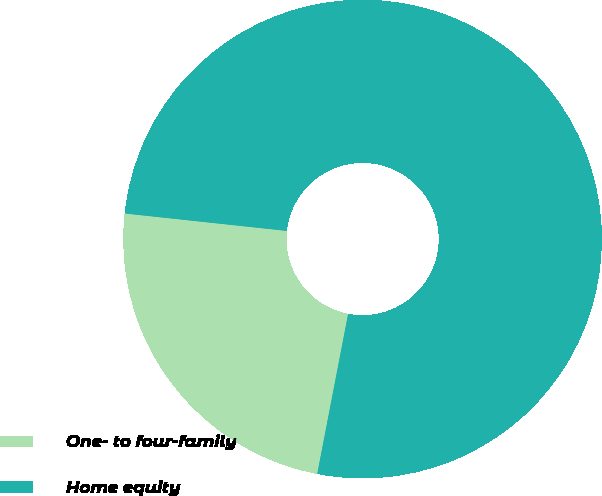Convert chart. <chart><loc_0><loc_0><loc_500><loc_500><pie_chart><fcel>One- to four-family<fcel>Home equity<nl><fcel>23.67%<fcel>76.33%<nl></chart> 